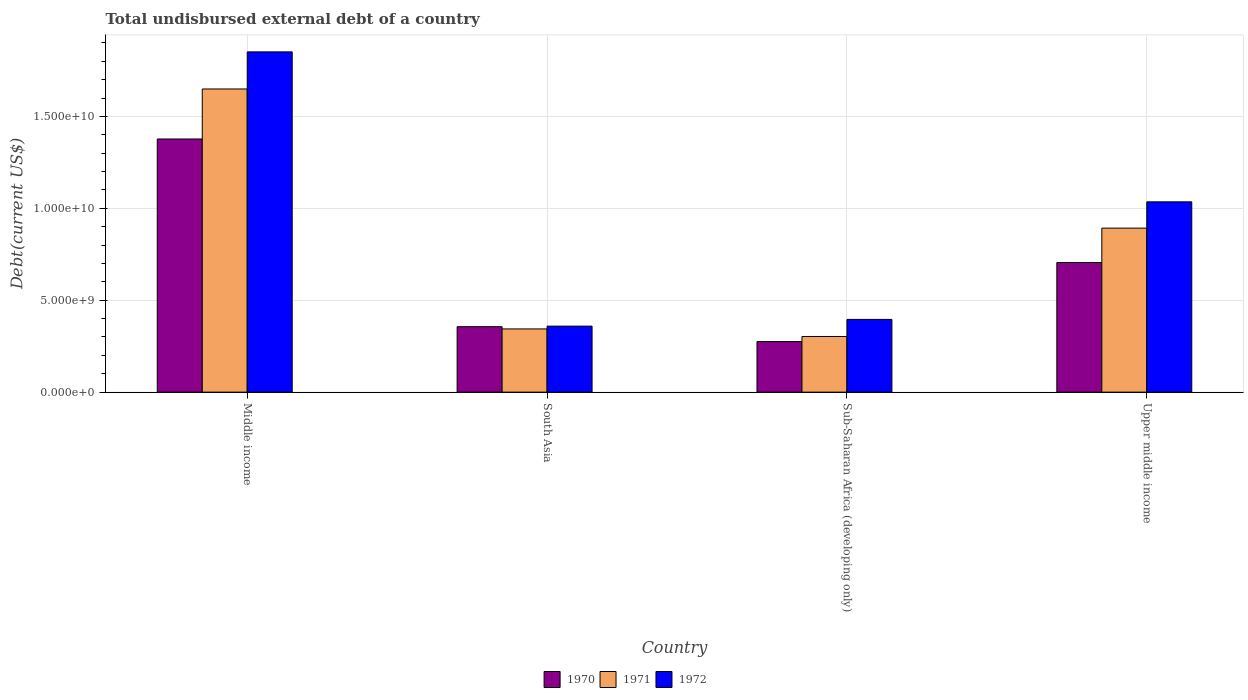Are the number of bars on each tick of the X-axis equal?
Your answer should be very brief. Yes. How many bars are there on the 2nd tick from the left?
Ensure brevity in your answer.  3. How many bars are there on the 1st tick from the right?
Ensure brevity in your answer.  3. What is the total undisbursed external debt in 1971 in Sub-Saharan Africa (developing only)?
Offer a terse response. 3.03e+09. Across all countries, what is the maximum total undisbursed external debt in 1971?
Your response must be concise. 1.65e+1. Across all countries, what is the minimum total undisbursed external debt in 1972?
Make the answer very short. 3.59e+09. In which country was the total undisbursed external debt in 1971 minimum?
Your response must be concise. Sub-Saharan Africa (developing only). What is the total total undisbursed external debt in 1972 in the graph?
Keep it short and to the point. 3.64e+1. What is the difference between the total undisbursed external debt in 1971 in South Asia and that in Upper middle income?
Keep it short and to the point. -5.48e+09. What is the difference between the total undisbursed external debt in 1971 in Middle income and the total undisbursed external debt in 1972 in South Asia?
Your answer should be very brief. 1.29e+1. What is the average total undisbursed external debt in 1970 per country?
Offer a terse response. 6.78e+09. What is the difference between the total undisbursed external debt of/in 1972 and total undisbursed external debt of/in 1970 in Middle income?
Offer a terse response. 4.74e+09. What is the ratio of the total undisbursed external debt in 1972 in Middle income to that in South Asia?
Ensure brevity in your answer.  5.15. Is the total undisbursed external debt in 1972 in Sub-Saharan Africa (developing only) less than that in Upper middle income?
Keep it short and to the point. Yes. Is the difference between the total undisbursed external debt in 1972 in Middle income and Upper middle income greater than the difference between the total undisbursed external debt in 1970 in Middle income and Upper middle income?
Make the answer very short. Yes. What is the difference between the highest and the second highest total undisbursed external debt in 1972?
Keep it short and to the point. 6.39e+09. What is the difference between the highest and the lowest total undisbursed external debt in 1972?
Offer a very short reply. 1.49e+1. In how many countries, is the total undisbursed external debt in 1970 greater than the average total undisbursed external debt in 1970 taken over all countries?
Offer a terse response. 2. Is the sum of the total undisbursed external debt in 1970 in Middle income and Upper middle income greater than the maximum total undisbursed external debt in 1971 across all countries?
Your answer should be compact. Yes. Is it the case that in every country, the sum of the total undisbursed external debt in 1970 and total undisbursed external debt in 1972 is greater than the total undisbursed external debt in 1971?
Provide a short and direct response. Yes. How many countries are there in the graph?
Give a very brief answer. 4. What is the difference between two consecutive major ticks on the Y-axis?
Your answer should be compact. 5.00e+09. Are the values on the major ticks of Y-axis written in scientific E-notation?
Your answer should be very brief. Yes. Does the graph contain grids?
Provide a succinct answer. Yes. Where does the legend appear in the graph?
Your answer should be very brief. Bottom center. How many legend labels are there?
Keep it short and to the point. 3. What is the title of the graph?
Your answer should be compact. Total undisbursed external debt of a country. What is the label or title of the Y-axis?
Provide a succinct answer. Debt(current US$). What is the Debt(current US$) of 1970 in Middle income?
Offer a very short reply. 1.38e+1. What is the Debt(current US$) of 1971 in Middle income?
Your answer should be very brief. 1.65e+1. What is the Debt(current US$) in 1972 in Middle income?
Keep it short and to the point. 1.85e+1. What is the Debt(current US$) of 1970 in South Asia?
Offer a terse response. 3.56e+09. What is the Debt(current US$) of 1971 in South Asia?
Your answer should be very brief. 3.44e+09. What is the Debt(current US$) in 1972 in South Asia?
Give a very brief answer. 3.59e+09. What is the Debt(current US$) of 1970 in Sub-Saharan Africa (developing only)?
Offer a very short reply. 2.75e+09. What is the Debt(current US$) of 1971 in Sub-Saharan Africa (developing only)?
Give a very brief answer. 3.03e+09. What is the Debt(current US$) in 1972 in Sub-Saharan Africa (developing only)?
Your response must be concise. 3.96e+09. What is the Debt(current US$) of 1970 in Upper middle income?
Give a very brief answer. 7.05e+09. What is the Debt(current US$) in 1971 in Upper middle income?
Ensure brevity in your answer.  8.92e+09. What is the Debt(current US$) of 1972 in Upper middle income?
Your answer should be very brief. 1.04e+1. Across all countries, what is the maximum Debt(current US$) in 1970?
Provide a succinct answer. 1.38e+1. Across all countries, what is the maximum Debt(current US$) in 1971?
Ensure brevity in your answer.  1.65e+1. Across all countries, what is the maximum Debt(current US$) in 1972?
Give a very brief answer. 1.85e+1. Across all countries, what is the minimum Debt(current US$) of 1970?
Your answer should be very brief. 2.75e+09. Across all countries, what is the minimum Debt(current US$) in 1971?
Keep it short and to the point. 3.03e+09. Across all countries, what is the minimum Debt(current US$) of 1972?
Provide a short and direct response. 3.59e+09. What is the total Debt(current US$) of 1970 in the graph?
Your answer should be very brief. 2.71e+1. What is the total Debt(current US$) in 1971 in the graph?
Offer a terse response. 3.19e+1. What is the total Debt(current US$) of 1972 in the graph?
Provide a succinct answer. 3.64e+1. What is the difference between the Debt(current US$) in 1970 in Middle income and that in South Asia?
Your answer should be compact. 1.02e+1. What is the difference between the Debt(current US$) in 1971 in Middle income and that in South Asia?
Provide a short and direct response. 1.31e+1. What is the difference between the Debt(current US$) in 1972 in Middle income and that in South Asia?
Make the answer very short. 1.49e+1. What is the difference between the Debt(current US$) of 1970 in Middle income and that in Sub-Saharan Africa (developing only)?
Make the answer very short. 1.10e+1. What is the difference between the Debt(current US$) of 1971 in Middle income and that in Sub-Saharan Africa (developing only)?
Offer a very short reply. 1.35e+1. What is the difference between the Debt(current US$) of 1972 in Middle income and that in Sub-Saharan Africa (developing only)?
Ensure brevity in your answer.  1.46e+1. What is the difference between the Debt(current US$) of 1970 in Middle income and that in Upper middle income?
Offer a terse response. 6.72e+09. What is the difference between the Debt(current US$) in 1971 in Middle income and that in Upper middle income?
Make the answer very short. 7.57e+09. What is the difference between the Debt(current US$) in 1972 in Middle income and that in Upper middle income?
Your answer should be very brief. 8.16e+09. What is the difference between the Debt(current US$) in 1970 in South Asia and that in Sub-Saharan Africa (developing only)?
Your answer should be very brief. 8.09e+08. What is the difference between the Debt(current US$) in 1971 in South Asia and that in Sub-Saharan Africa (developing only)?
Your answer should be compact. 4.11e+08. What is the difference between the Debt(current US$) of 1972 in South Asia and that in Sub-Saharan Africa (developing only)?
Your response must be concise. -3.67e+08. What is the difference between the Debt(current US$) in 1970 in South Asia and that in Upper middle income?
Ensure brevity in your answer.  -3.49e+09. What is the difference between the Debt(current US$) in 1971 in South Asia and that in Upper middle income?
Your answer should be compact. -5.48e+09. What is the difference between the Debt(current US$) of 1972 in South Asia and that in Upper middle income?
Provide a succinct answer. -6.76e+09. What is the difference between the Debt(current US$) in 1970 in Sub-Saharan Africa (developing only) and that in Upper middle income?
Provide a succinct answer. -4.30e+09. What is the difference between the Debt(current US$) in 1971 in Sub-Saharan Africa (developing only) and that in Upper middle income?
Give a very brief answer. -5.89e+09. What is the difference between the Debt(current US$) in 1972 in Sub-Saharan Africa (developing only) and that in Upper middle income?
Provide a succinct answer. -6.39e+09. What is the difference between the Debt(current US$) of 1970 in Middle income and the Debt(current US$) of 1971 in South Asia?
Your answer should be very brief. 1.03e+1. What is the difference between the Debt(current US$) of 1970 in Middle income and the Debt(current US$) of 1972 in South Asia?
Offer a terse response. 1.02e+1. What is the difference between the Debt(current US$) in 1971 in Middle income and the Debt(current US$) in 1972 in South Asia?
Your answer should be very brief. 1.29e+1. What is the difference between the Debt(current US$) in 1970 in Middle income and the Debt(current US$) in 1971 in Sub-Saharan Africa (developing only)?
Offer a terse response. 1.07e+1. What is the difference between the Debt(current US$) of 1970 in Middle income and the Debt(current US$) of 1972 in Sub-Saharan Africa (developing only)?
Your answer should be very brief. 9.81e+09. What is the difference between the Debt(current US$) of 1971 in Middle income and the Debt(current US$) of 1972 in Sub-Saharan Africa (developing only)?
Your response must be concise. 1.25e+1. What is the difference between the Debt(current US$) in 1970 in Middle income and the Debt(current US$) in 1971 in Upper middle income?
Offer a very short reply. 4.85e+09. What is the difference between the Debt(current US$) of 1970 in Middle income and the Debt(current US$) of 1972 in Upper middle income?
Ensure brevity in your answer.  3.42e+09. What is the difference between the Debt(current US$) in 1971 in Middle income and the Debt(current US$) in 1972 in Upper middle income?
Offer a terse response. 6.14e+09. What is the difference between the Debt(current US$) of 1970 in South Asia and the Debt(current US$) of 1971 in Sub-Saharan Africa (developing only)?
Your response must be concise. 5.33e+08. What is the difference between the Debt(current US$) of 1970 in South Asia and the Debt(current US$) of 1972 in Sub-Saharan Africa (developing only)?
Your answer should be compact. -3.97e+08. What is the difference between the Debt(current US$) of 1971 in South Asia and the Debt(current US$) of 1972 in Sub-Saharan Africa (developing only)?
Give a very brief answer. -5.18e+08. What is the difference between the Debt(current US$) in 1970 in South Asia and the Debt(current US$) in 1971 in Upper middle income?
Keep it short and to the point. -5.36e+09. What is the difference between the Debt(current US$) in 1970 in South Asia and the Debt(current US$) in 1972 in Upper middle income?
Provide a succinct answer. -6.79e+09. What is the difference between the Debt(current US$) of 1971 in South Asia and the Debt(current US$) of 1972 in Upper middle income?
Your answer should be compact. -6.91e+09. What is the difference between the Debt(current US$) of 1970 in Sub-Saharan Africa (developing only) and the Debt(current US$) of 1971 in Upper middle income?
Your answer should be compact. -6.17e+09. What is the difference between the Debt(current US$) in 1970 in Sub-Saharan Africa (developing only) and the Debt(current US$) in 1972 in Upper middle income?
Offer a very short reply. -7.60e+09. What is the difference between the Debt(current US$) of 1971 in Sub-Saharan Africa (developing only) and the Debt(current US$) of 1972 in Upper middle income?
Ensure brevity in your answer.  -7.32e+09. What is the average Debt(current US$) of 1970 per country?
Your answer should be compact. 6.78e+09. What is the average Debt(current US$) in 1971 per country?
Offer a terse response. 7.97e+09. What is the average Debt(current US$) in 1972 per country?
Make the answer very short. 9.10e+09. What is the difference between the Debt(current US$) in 1970 and Debt(current US$) in 1971 in Middle income?
Make the answer very short. -2.72e+09. What is the difference between the Debt(current US$) in 1970 and Debt(current US$) in 1972 in Middle income?
Give a very brief answer. -4.74e+09. What is the difference between the Debt(current US$) of 1971 and Debt(current US$) of 1972 in Middle income?
Provide a succinct answer. -2.02e+09. What is the difference between the Debt(current US$) of 1970 and Debt(current US$) of 1971 in South Asia?
Offer a very short reply. 1.21e+08. What is the difference between the Debt(current US$) of 1970 and Debt(current US$) of 1972 in South Asia?
Your answer should be very brief. -3.02e+07. What is the difference between the Debt(current US$) in 1971 and Debt(current US$) in 1972 in South Asia?
Keep it short and to the point. -1.51e+08. What is the difference between the Debt(current US$) of 1970 and Debt(current US$) of 1971 in Sub-Saharan Africa (developing only)?
Your answer should be very brief. -2.76e+08. What is the difference between the Debt(current US$) in 1970 and Debt(current US$) in 1972 in Sub-Saharan Africa (developing only)?
Ensure brevity in your answer.  -1.21e+09. What is the difference between the Debt(current US$) of 1971 and Debt(current US$) of 1972 in Sub-Saharan Africa (developing only)?
Ensure brevity in your answer.  -9.29e+08. What is the difference between the Debt(current US$) of 1970 and Debt(current US$) of 1971 in Upper middle income?
Keep it short and to the point. -1.87e+09. What is the difference between the Debt(current US$) in 1970 and Debt(current US$) in 1972 in Upper middle income?
Your answer should be very brief. -3.30e+09. What is the difference between the Debt(current US$) in 1971 and Debt(current US$) in 1972 in Upper middle income?
Your answer should be compact. -1.43e+09. What is the ratio of the Debt(current US$) of 1970 in Middle income to that in South Asia?
Your response must be concise. 3.87. What is the ratio of the Debt(current US$) of 1971 in Middle income to that in South Asia?
Provide a short and direct response. 4.8. What is the ratio of the Debt(current US$) in 1972 in Middle income to that in South Asia?
Make the answer very short. 5.15. What is the ratio of the Debt(current US$) of 1970 in Middle income to that in Sub-Saharan Africa (developing only)?
Provide a succinct answer. 5. What is the ratio of the Debt(current US$) of 1971 in Middle income to that in Sub-Saharan Africa (developing only)?
Provide a succinct answer. 5.45. What is the ratio of the Debt(current US$) in 1972 in Middle income to that in Sub-Saharan Africa (developing only)?
Your answer should be compact. 4.68. What is the ratio of the Debt(current US$) of 1970 in Middle income to that in Upper middle income?
Offer a very short reply. 1.95. What is the ratio of the Debt(current US$) in 1971 in Middle income to that in Upper middle income?
Make the answer very short. 1.85. What is the ratio of the Debt(current US$) in 1972 in Middle income to that in Upper middle income?
Offer a very short reply. 1.79. What is the ratio of the Debt(current US$) of 1970 in South Asia to that in Sub-Saharan Africa (developing only)?
Your answer should be very brief. 1.29. What is the ratio of the Debt(current US$) in 1971 in South Asia to that in Sub-Saharan Africa (developing only)?
Provide a succinct answer. 1.14. What is the ratio of the Debt(current US$) in 1972 in South Asia to that in Sub-Saharan Africa (developing only)?
Make the answer very short. 0.91. What is the ratio of the Debt(current US$) in 1970 in South Asia to that in Upper middle income?
Your answer should be very brief. 0.5. What is the ratio of the Debt(current US$) of 1971 in South Asia to that in Upper middle income?
Your response must be concise. 0.39. What is the ratio of the Debt(current US$) of 1972 in South Asia to that in Upper middle income?
Make the answer very short. 0.35. What is the ratio of the Debt(current US$) in 1970 in Sub-Saharan Africa (developing only) to that in Upper middle income?
Your response must be concise. 0.39. What is the ratio of the Debt(current US$) in 1971 in Sub-Saharan Africa (developing only) to that in Upper middle income?
Your response must be concise. 0.34. What is the ratio of the Debt(current US$) in 1972 in Sub-Saharan Africa (developing only) to that in Upper middle income?
Keep it short and to the point. 0.38. What is the difference between the highest and the second highest Debt(current US$) in 1970?
Keep it short and to the point. 6.72e+09. What is the difference between the highest and the second highest Debt(current US$) of 1971?
Ensure brevity in your answer.  7.57e+09. What is the difference between the highest and the second highest Debt(current US$) of 1972?
Offer a terse response. 8.16e+09. What is the difference between the highest and the lowest Debt(current US$) in 1970?
Your response must be concise. 1.10e+1. What is the difference between the highest and the lowest Debt(current US$) in 1971?
Provide a succinct answer. 1.35e+1. What is the difference between the highest and the lowest Debt(current US$) of 1972?
Offer a terse response. 1.49e+1. 